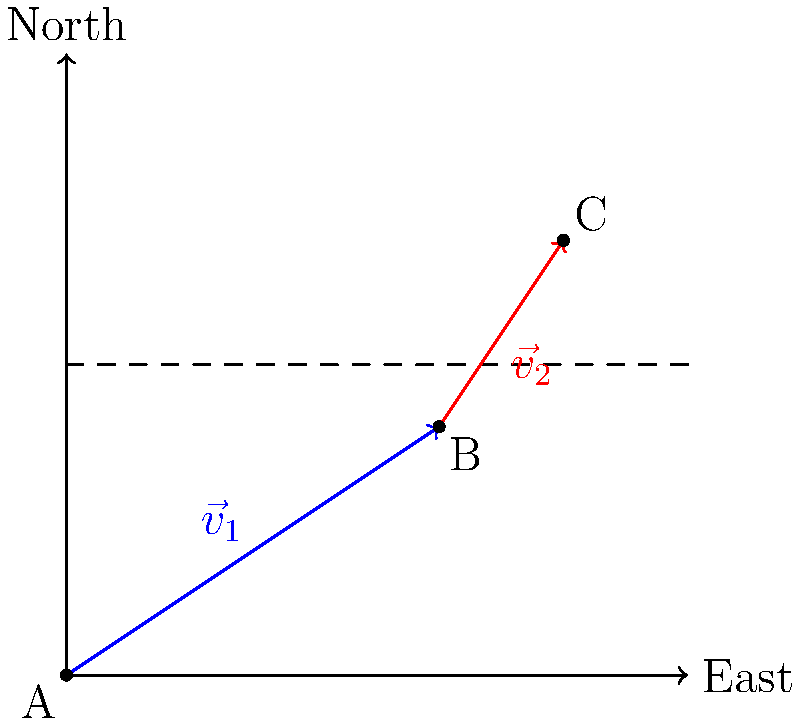In Cape Coral's canal system, water flows from point A to point B with velocity vector $\vec{v}_1 = 60\hat{i} + 40\hat{j}$ (in m/h), and then from B to C with velocity vector $\vec{v}_2 = 20\hat{i} + 30\hat{j}$ (in m/h). Calculate the magnitude of the resultant velocity vector $\vec{v}_R$ from A to C. To solve this problem, we'll follow these steps:

1) First, we need to find the resultant velocity vector $\vec{v}_R$. This is the sum of $\vec{v}_1$ and $\vec{v}_2$:

   $\vec{v}_R = \vec{v}_1 + \vec{v}_2$

2) Let's add the components:
   
   $\vec{v}_R = (60\hat{i} + 40\hat{j}) + (20\hat{i} + 30\hat{j})$
   $\vec{v}_R = (60 + 20)\hat{i} + (40 + 30)\hat{j}$
   $\vec{v}_R = 80\hat{i} + 70\hat{j}$

3) Now that we have the resultant vector, we need to calculate its magnitude. The magnitude of a vector $\vec{a} = a_x\hat{i} + a_y\hat{j}$ is given by:

   $|\vec{a}| = \sqrt{a_x^2 + a_y^2}$

4) Applying this to our resultant vector:

   $|\vec{v}_R| = \sqrt{80^2 + 70^2}$

5) Calculate:

   $|\vec{v}_R| = \sqrt{6400 + 4900} = \sqrt{11300} \approx 106.30$ m/h

Therefore, the magnitude of the resultant velocity vector is approximately 106.30 m/h.
Answer: 106.30 m/h 